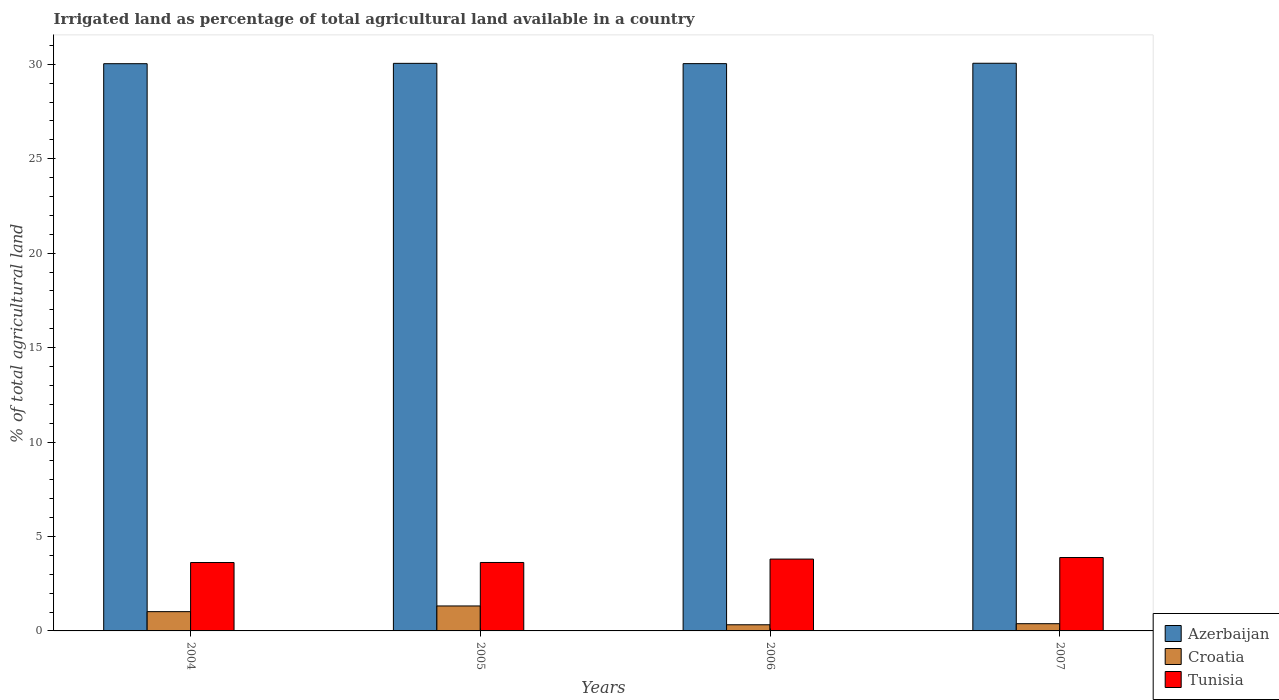How many groups of bars are there?
Your response must be concise. 4. Are the number of bars per tick equal to the number of legend labels?
Your answer should be compact. Yes. How many bars are there on the 2nd tick from the right?
Give a very brief answer. 3. In how many cases, is the number of bars for a given year not equal to the number of legend labels?
Provide a short and direct response. 0. What is the percentage of irrigated land in Croatia in 2007?
Offer a terse response. 0.38. Across all years, what is the maximum percentage of irrigated land in Azerbaijan?
Ensure brevity in your answer.  30.06. Across all years, what is the minimum percentage of irrigated land in Croatia?
Your answer should be compact. 0.33. In which year was the percentage of irrigated land in Croatia minimum?
Your answer should be very brief. 2006. What is the total percentage of irrigated land in Azerbaijan in the graph?
Provide a short and direct response. 120.17. What is the difference between the percentage of irrigated land in Croatia in 2004 and that in 2006?
Ensure brevity in your answer.  0.7. What is the difference between the percentage of irrigated land in Croatia in 2005 and the percentage of irrigated land in Azerbaijan in 2004?
Keep it short and to the point. -28.71. What is the average percentage of irrigated land in Croatia per year?
Your response must be concise. 0.76. In the year 2006, what is the difference between the percentage of irrigated land in Azerbaijan and percentage of irrigated land in Croatia?
Give a very brief answer. 29.71. What is the ratio of the percentage of irrigated land in Tunisia in 2004 to that in 2005?
Give a very brief answer. 1. Is the percentage of irrigated land in Azerbaijan in 2006 less than that in 2007?
Keep it short and to the point. Yes. Is the difference between the percentage of irrigated land in Azerbaijan in 2004 and 2005 greater than the difference between the percentage of irrigated land in Croatia in 2004 and 2005?
Give a very brief answer. Yes. What is the difference between the highest and the second highest percentage of irrigated land in Tunisia?
Ensure brevity in your answer.  0.08. What is the difference between the highest and the lowest percentage of irrigated land in Tunisia?
Your answer should be very brief. 0.26. In how many years, is the percentage of irrigated land in Tunisia greater than the average percentage of irrigated land in Tunisia taken over all years?
Provide a short and direct response. 2. What does the 1st bar from the left in 2004 represents?
Give a very brief answer. Azerbaijan. What does the 2nd bar from the right in 2005 represents?
Keep it short and to the point. Croatia. Is it the case that in every year, the sum of the percentage of irrigated land in Azerbaijan and percentage of irrigated land in Tunisia is greater than the percentage of irrigated land in Croatia?
Make the answer very short. Yes. How many bars are there?
Your answer should be very brief. 12. Are all the bars in the graph horizontal?
Give a very brief answer. No. What is the difference between two consecutive major ticks on the Y-axis?
Provide a short and direct response. 5. Does the graph contain any zero values?
Your answer should be compact. No. How many legend labels are there?
Keep it short and to the point. 3. How are the legend labels stacked?
Your answer should be compact. Vertical. What is the title of the graph?
Make the answer very short. Irrigated land as percentage of total agricultural land available in a country. What is the label or title of the Y-axis?
Ensure brevity in your answer.  % of total agricultural land. What is the % of total agricultural land in Azerbaijan in 2004?
Provide a succinct answer. 30.03. What is the % of total agricultural land of Croatia in 2004?
Make the answer very short. 1.02. What is the % of total agricultural land of Tunisia in 2004?
Give a very brief answer. 3.62. What is the % of total agricultural land of Azerbaijan in 2005?
Your answer should be compact. 30.05. What is the % of total agricultural land of Croatia in 2005?
Keep it short and to the point. 1.32. What is the % of total agricultural land of Tunisia in 2005?
Give a very brief answer. 3.62. What is the % of total agricultural land of Azerbaijan in 2006?
Make the answer very short. 30.04. What is the % of total agricultural land in Croatia in 2006?
Provide a succinct answer. 0.33. What is the % of total agricultural land in Tunisia in 2006?
Offer a terse response. 3.8. What is the % of total agricultural land of Azerbaijan in 2007?
Offer a very short reply. 30.06. What is the % of total agricultural land of Croatia in 2007?
Your response must be concise. 0.38. What is the % of total agricultural land of Tunisia in 2007?
Offer a terse response. 3.89. Across all years, what is the maximum % of total agricultural land in Azerbaijan?
Ensure brevity in your answer.  30.06. Across all years, what is the maximum % of total agricultural land of Croatia?
Your response must be concise. 1.32. Across all years, what is the maximum % of total agricultural land of Tunisia?
Offer a terse response. 3.89. Across all years, what is the minimum % of total agricultural land of Azerbaijan?
Offer a very short reply. 30.03. Across all years, what is the minimum % of total agricultural land in Croatia?
Your answer should be compact. 0.33. Across all years, what is the minimum % of total agricultural land of Tunisia?
Provide a short and direct response. 3.62. What is the total % of total agricultural land of Azerbaijan in the graph?
Give a very brief answer. 120.17. What is the total % of total agricultural land in Croatia in the graph?
Give a very brief answer. 3.05. What is the total % of total agricultural land of Tunisia in the graph?
Your response must be concise. 14.93. What is the difference between the % of total agricultural land in Azerbaijan in 2004 and that in 2005?
Make the answer very short. -0.02. What is the difference between the % of total agricultural land of Croatia in 2004 and that in 2005?
Offer a very short reply. -0.3. What is the difference between the % of total agricultural land of Tunisia in 2004 and that in 2005?
Provide a short and direct response. -0. What is the difference between the % of total agricultural land in Azerbaijan in 2004 and that in 2006?
Offer a terse response. -0. What is the difference between the % of total agricultural land in Croatia in 2004 and that in 2006?
Your answer should be compact. 0.7. What is the difference between the % of total agricultural land of Tunisia in 2004 and that in 2006?
Keep it short and to the point. -0.18. What is the difference between the % of total agricultural land in Azerbaijan in 2004 and that in 2007?
Your answer should be very brief. -0.02. What is the difference between the % of total agricultural land of Croatia in 2004 and that in 2007?
Your response must be concise. 0.64. What is the difference between the % of total agricultural land of Tunisia in 2004 and that in 2007?
Keep it short and to the point. -0.26. What is the difference between the % of total agricultural land in Azerbaijan in 2005 and that in 2006?
Provide a short and direct response. 0.02. What is the difference between the % of total agricultural land of Tunisia in 2005 and that in 2006?
Your answer should be compact. -0.18. What is the difference between the % of total agricultural land in Azerbaijan in 2005 and that in 2007?
Ensure brevity in your answer.  -0. What is the difference between the % of total agricultural land of Croatia in 2005 and that in 2007?
Keep it short and to the point. 0.94. What is the difference between the % of total agricultural land of Tunisia in 2005 and that in 2007?
Give a very brief answer. -0.26. What is the difference between the % of total agricultural land in Azerbaijan in 2006 and that in 2007?
Keep it short and to the point. -0.02. What is the difference between the % of total agricultural land of Croatia in 2006 and that in 2007?
Keep it short and to the point. -0.06. What is the difference between the % of total agricultural land of Tunisia in 2006 and that in 2007?
Ensure brevity in your answer.  -0.08. What is the difference between the % of total agricultural land in Azerbaijan in 2004 and the % of total agricultural land in Croatia in 2005?
Keep it short and to the point. 28.71. What is the difference between the % of total agricultural land of Azerbaijan in 2004 and the % of total agricultural land of Tunisia in 2005?
Keep it short and to the point. 26.41. What is the difference between the % of total agricultural land of Croatia in 2004 and the % of total agricultural land of Tunisia in 2005?
Offer a very short reply. -2.6. What is the difference between the % of total agricultural land in Azerbaijan in 2004 and the % of total agricultural land in Croatia in 2006?
Offer a very short reply. 29.71. What is the difference between the % of total agricultural land in Azerbaijan in 2004 and the % of total agricultural land in Tunisia in 2006?
Make the answer very short. 26.23. What is the difference between the % of total agricultural land of Croatia in 2004 and the % of total agricultural land of Tunisia in 2006?
Your answer should be compact. -2.78. What is the difference between the % of total agricultural land of Azerbaijan in 2004 and the % of total agricultural land of Croatia in 2007?
Your answer should be very brief. 29.65. What is the difference between the % of total agricultural land of Azerbaijan in 2004 and the % of total agricultural land of Tunisia in 2007?
Your answer should be very brief. 26.15. What is the difference between the % of total agricultural land in Croatia in 2004 and the % of total agricultural land in Tunisia in 2007?
Keep it short and to the point. -2.87. What is the difference between the % of total agricultural land in Azerbaijan in 2005 and the % of total agricultural land in Croatia in 2006?
Make the answer very short. 29.73. What is the difference between the % of total agricultural land of Azerbaijan in 2005 and the % of total agricultural land of Tunisia in 2006?
Your answer should be very brief. 26.25. What is the difference between the % of total agricultural land in Croatia in 2005 and the % of total agricultural land in Tunisia in 2006?
Keep it short and to the point. -2.48. What is the difference between the % of total agricultural land of Azerbaijan in 2005 and the % of total agricultural land of Croatia in 2007?
Provide a succinct answer. 29.67. What is the difference between the % of total agricultural land in Azerbaijan in 2005 and the % of total agricultural land in Tunisia in 2007?
Make the answer very short. 26.17. What is the difference between the % of total agricultural land of Croatia in 2005 and the % of total agricultural land of Tunisia in 2007?
Ensure brevity in your answer.  -2.56. What is the difference between the % of total agricultural land in Azerbaijan in 2006 and the % of total agricultural land in Croatia in 2007?
Provide a succinct answer. 29.65. What is the difference between the % of total agricultural land of Azerbaijan in 2006 and the % of total agricultural land of Tunisia in 2007?
Make the answer very short. 26.15. What is the difference between the % of total agricultural land of Croatia in 2006 and the % of total agricultural land of Tunisia in 2007?
Make the answer very short. -3.56. What is the average % of total agricultural land of Azerbaijan per year?
Your answer should be compact. 30.04. What is the average % of total agricultural land of Croatia per year?
Ensure brevity in your answer.  0.76. What is the average % of total agricultural land in Tunisia per year?
Make the answer very short. 3.73. In the year 2004, what is the difference between the % of total agricultural land in Azerbaijan and % of total agricultural land in Croatia?
Provide a succinct answer. 29.01. In the year 2004, what is the difference between the % of total agricultural land in Azerbaijan and % of total agricultural land in Tunisia?
Ensure brevity in your answer.  26.41. In the year 2004, what is the difference between the % of total agricultural land of Croatia and % of total agricultural land of Tunisia?
Provide a succinct answer. -2.6. In the year 2005, what is the difference between the % of total agricultural land of Azerbaijan and % of total agricultural land of Croatia?
Ensure brevity in your answer.  28.73. In the year 2005, what is the difference between the % of total agricultural land in Azerbaijan and % of total agricultural land in Tunisia?
Provide a short and direct response. 26.43. In the year 2005, what is the difference between the % of total agricultural land in Croatia and % of total agricultural land in Tunisia?
Your answer should be compact. -2.3. In the year 2006, what is the difference between the % of total agricultural land in Azerbaijan and % of total agricultural land in Croatia?
Your response must be concise. 29.71. In the year 2006, what is the difference between the % of total agricultural land in Azerbaijan and % of total agricultural land in Tunisia?
Ensure brevity in your answer.  26.23. In the year 2006, what is the difference between the % of total agricultural land of Croatia and % of total agricultural land of Tunisia?
Provide a succinct answer. -3.48. In the year 2007, what is the difference between the % of total agricultural land of Azerbaijan and % of total agricultural land of Croatia?
Ensure brevity in your answer.  29.67. In the year 2007, what is the difference between the % of total agricultural land of Azerbaijan and % of total agricultural land of Tunisia?
Give a very brief answer. 26.17. In the year 2007, what is the difference between the % of total agricultural land of Croatia and % of total agricultural land of Tunisia?
Give a very brief answer. -3.5. What is the ratio of the % of total agricultural land of Azerbaijan in 2004 to that in 2005?
Your answer should be very brief. 1. What is the ratio of the % of total agricultural land of Croatia in 2004 to that in 2005?
Offer a very short reply. 0.77. What is the ratio of the % of total agricultural land in Tunisia in 2004 to that in 2005?
Your answer should be very brief. 1. What is the ratio of the % of total agricultural land of Azerbaijan in 2004 to that in 2006?
Make the answer very short. 1. What is the ratio of the % of total agricultural land in Croatia in 2004 to that in 2006?
Your answer should be compact. 3.14. What is the ratio of the % of total agricultural land of Tunisia in 2004 to that in 2006?
Your answer should be compact. 0.95. What is the ratio of the % of total agricultural land of Azerbaijan in 2004 to that in 2007?
Provide a succinct answer. 1. What is the ratio of the % of total agricultural land of Croatia in 2004 to that in 2007?
Your response must be concise. 2.67. What is the ratio of the % of total agricultural land in Tunisia in 2004 to that in 2007?
Provide a succinct answer. 0.93. What is the ratio of the % of total agricultural land of Azerbaijan in 2005 to that in 2006?
Give a very brief answer. 1. What is the ratio of the % of total agricultural land in Croatia in 2005 to that in 2006?
Offer a terse response. 4.06. What is the ratio of the % of total agricultural land of Tunisia in 2005 to that in 2006?
Your answer should be very brief. 0.95. What is the ratio of the % of total agricultural land of Azerbaijan in 2005 to that in 2007?
Your answer should be compact. 1. What is the ratio of the % of total agricultural land in Croatia in 2005 to that in 2007?
Provide a succinct answer. 3.45. What is the ratio of the % of total agricultural land in Tunisia in 2005 to that in 2007?
Provide a succinct answer. 0.93. What is the ratio of the % of total agricultural land of Croatia in 2006 to that in 2007?
Offer a terse response. 0.85. What is the ratio of the % of total agricultural land in Tunisia in 2006 to that in 2007?
Your response must be concise. 0.98. What is the difference between the highest and the second highest % of total agricultural land in Azerbaijan?
Provide a short and direct response. 0. What is the difference between the highest and the second highest % of total agricultural land in Croatia?
Your answer should be very brief. 0.3. What is the difference between the highest and the second highest % of total agricultural land in Tunisia?
Provide a succinct answer. 0.08. What is the difference between the highest and the lowest % of total agricultural land of Azerbaijan?
Ensure brevity in your answer.  0.02. What is the difference between the highest and the lowest % of total agricultural land in Tunisia?
Your response must be concise. 0.26. 